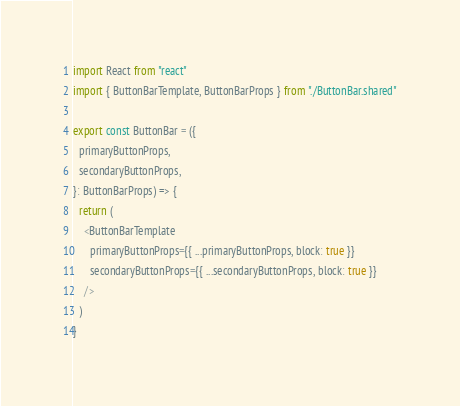Convert code to text. <code><loc_0><loc_0><loc_500><loc_500><_TypeScript_>import React from "react"
import { ButtonBarTemplate, ButtonBarProps } from "./ButtonBar.shared"

export const ButtonBar = ({
  primaryButtonProps,
  secondaryButtonProps,
}: ButtonBarProps) => {
  return (
    <ButtonBarTemplate
      primaryButtonProps={{ ...primaryButtonProps, block: true }}
      secondaryButtonProps={{ ...secondaryButtonProps, block: true }}
    />
  )
}
</code> 